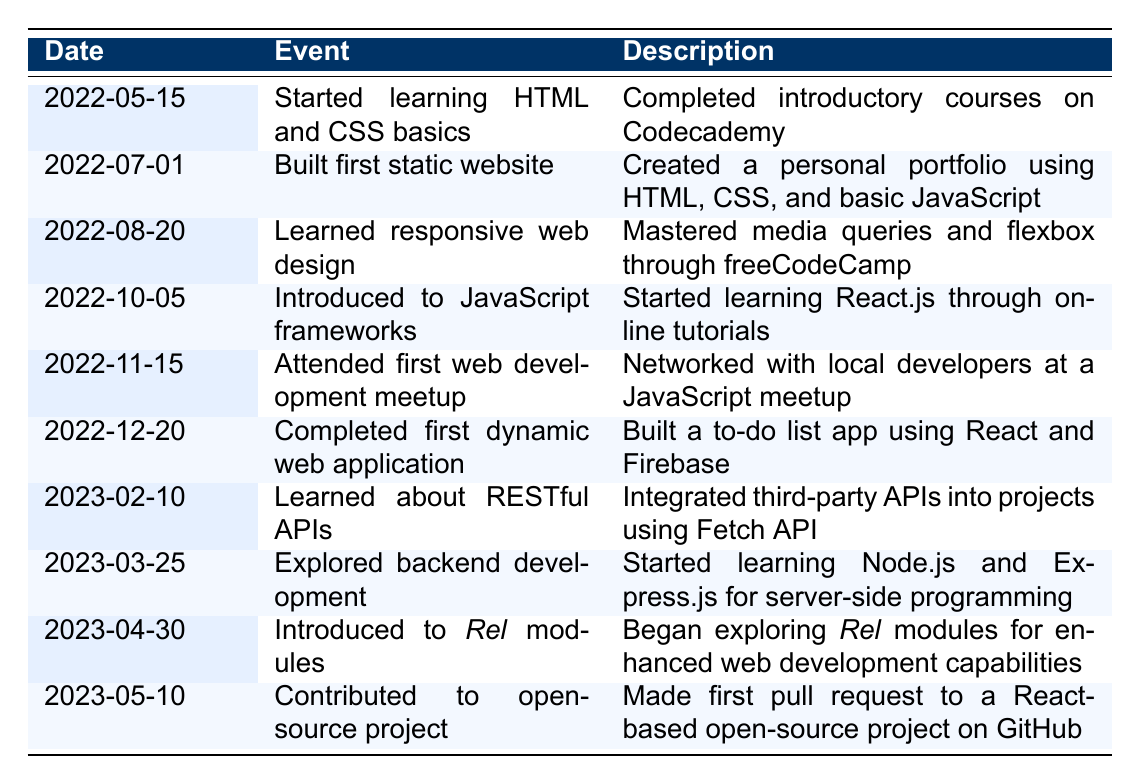What event occurred on 2022-07-01? The event listed for this date is "Built first static website". This can be found in the second row of the table, where I can see the date and corresponding event.
Answer: Built first static website Did the individual learn about RESTful APIs before learning about Node.js? By checking the dates, RESTful APIs were learned on 2023-02-10 and Node.js on 2023-03-25. Since February 10 is before March 25, the answer is yes.
Answer: Yes How many events were attended between August and December 2022? The events that fall between these dates are "Learned responsive web design", "Attended first web development meetup", and "Completed first dynamic web application", which totals to three events.
Answer: 3 What was the last milestone achieved before exploring _Rel_ modules? The last event before _Rel_ modules was "Explored backend development" on March 25, 2023. This information is clear in the sequence of the timeline events.
Answer: Explored backend development Was the individual introduced to any frameworks before building their first dynamic web application? The table shows that they were introduced to JavaScript frameworks on October 5, 2022, which is before they completed their first dynamic web application on December 20, 2022. Thus, the answer is yes.
Answer: Yes What is the difference in days between the event of "Started learning HTML and CSS basics" and "Contributed to open-source project"? The date of "Started learning HTML and CSS basics" is May 15, 2022, and "Contributed to open-source project" is May 10, 2023. The difference is 361 days. This is calculated by counting the days from one date to the other.
Answer: 361 List all events that occurred in April 2023. According to the table, there is only one event in April 2023: "Introduced to _Rel_ modules" on April 30, 2023. This can be found by scanning the timeline for April dates.
Answer: Introduced to _Rel_ modules How many months passed between starting to learn HTML/CSS and contributing to an open-source project? From May 15, 2022, to May 10, 2023, is nearly 12 months, calculating from May 2022 to May 2023, but since it ends right before the full month, it is just under 12 complete months.
Answer: Approximately 11 months 